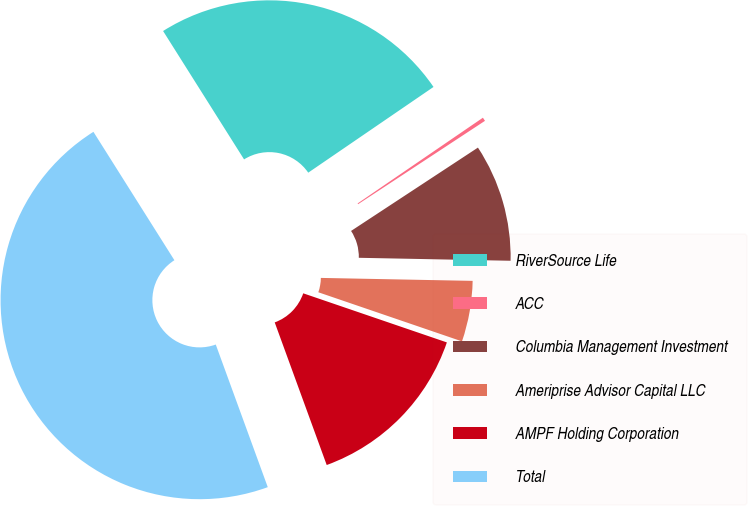Convert chart to OTSL. <chart><loc_0><loc_0><loc_500><loc_500><pie_chart><fcel>RiverSource Life<fcel>ACC<fcel>Columbia Management Investment<fcel>Ameriprise Advisor Capital LLC<fcel>AMPF Holding Corporation<fcel>Total<nl><fcel>24.4%<fcel>0.3%<fcel>9.56%<fcel>4.93%<fcel>14.19%<fcel>46.6%<nl></chart> 